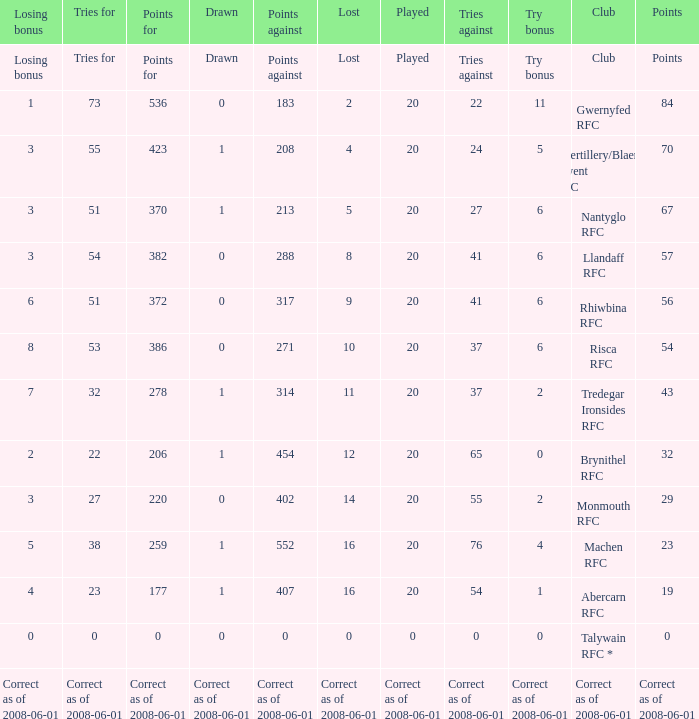If the points were 0, what were the tries for? 0.0. 